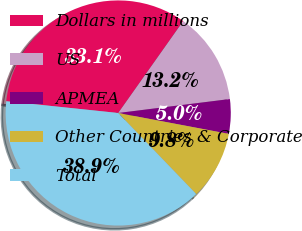Convert chart. <chart><loc_0><loc_0><loc_500><loc_500><pie_chart><fcel>Dollars in millions<fcel>US<fcel>APMEA<fcel>Other Countries & Corporate<fcel>Total<nl><fcel>33.13%<fcel>13.22%<fcel>4.95%<fcel>9.83%<fcel>38.86%<nl></chart> 